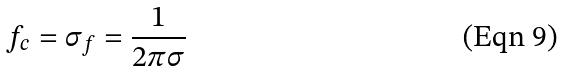Convert formula to latex. <formula><loc_0><loc_0><loc_500><loc_500>f _ { c } = \sigma _ { f } = \frac { 1 } { 2 \pi \sigma }</formula> 